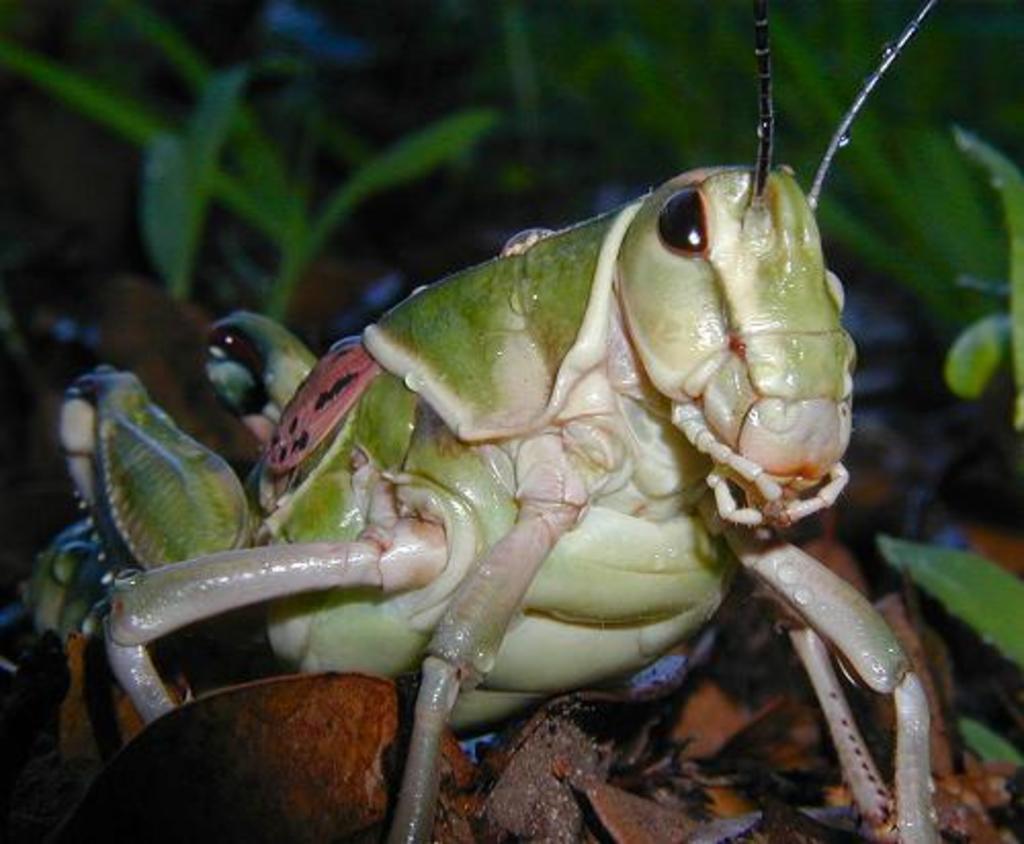In one or two sentences, can you explain what this image depicts? In the center of the image we can see grasshoppers. In the background there are plants. 